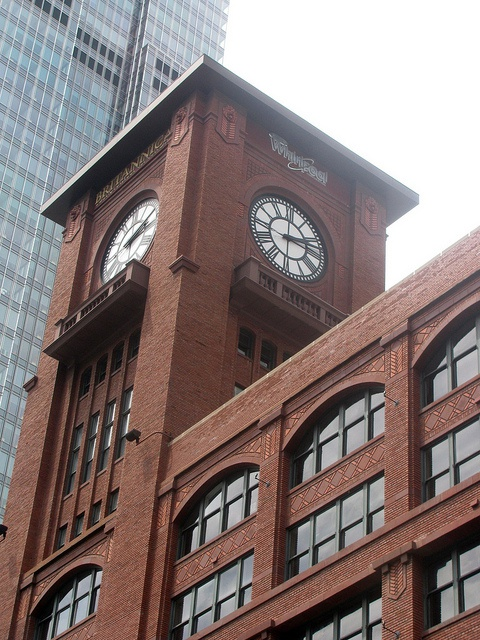Describe the objects in this image and their specific colors. I can see clock in darkgray, gray, lightgray, and purple tones and clock in darkgray, white, gray, and black tones in this image. 